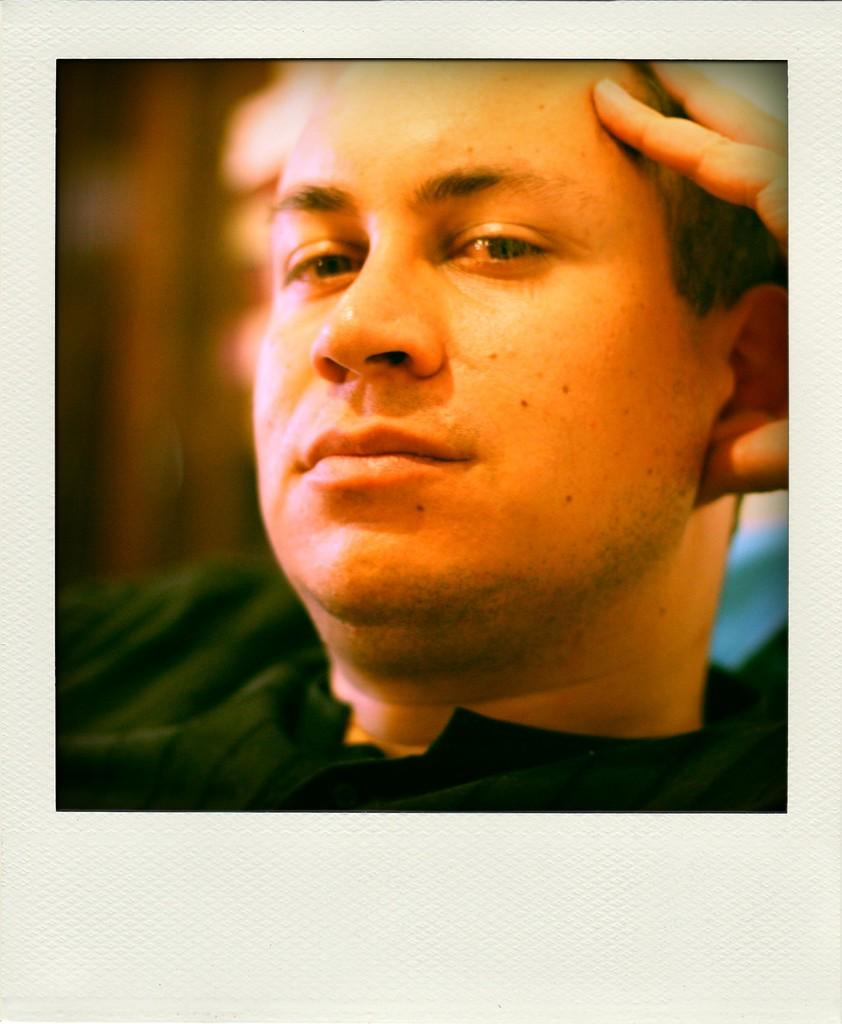What is the main subject of the image? There is a man in the image. What is the man doing in the image? The man is holding his head. What type of vase can be seen on the window in the image? There is no vase or window present in the image; it only features a man holding his head. 